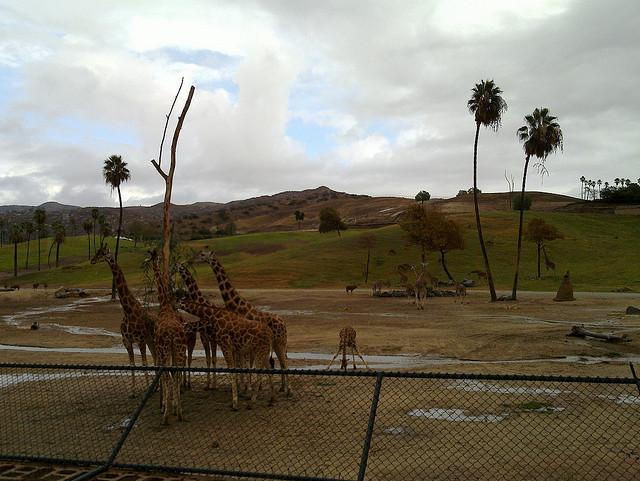What type of enclosure is shown? zoo 